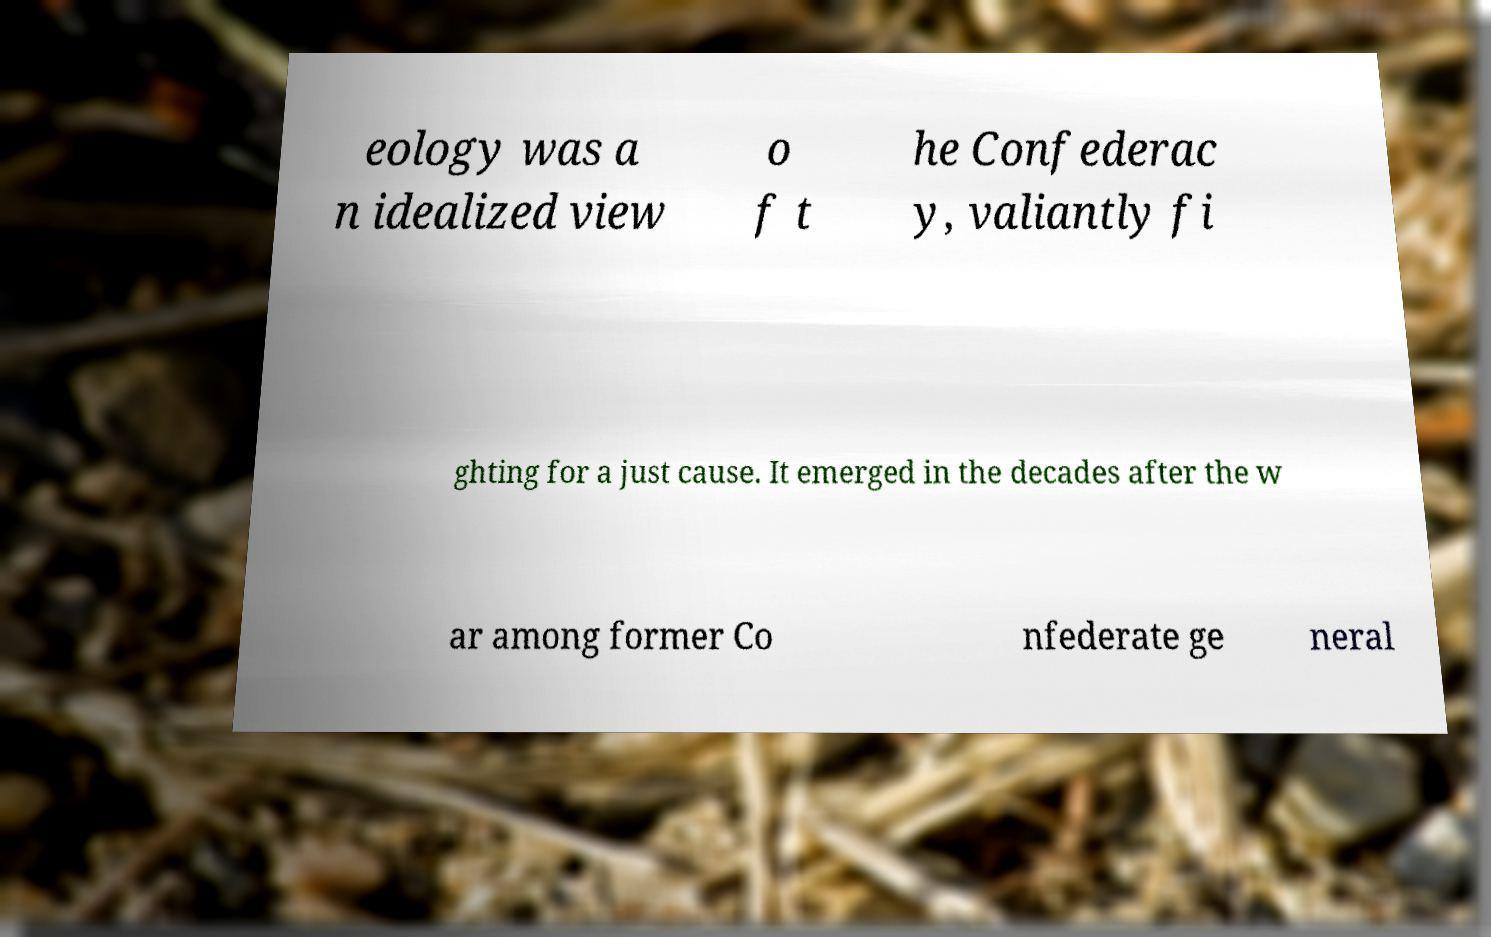There's text embedded in this image that I need extracted. Can you transcribe it verbatim? eology was a n idealized view o f t he Confederac y, valiantly fi ghting for a just cause. It emerged in the decades after the w ar among former Co nfederate ge neral 